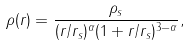Convert formula to latex. <formula><loc_0><loc_0><loc_500><loc_500>\rho ( r ) = \frac { \rho _ { s } } { ( r / r _ { s } ) ^ { \alpha } ( 1 + r / r _ { s } ) ^ { 3 - \alpha } } ,</formula> 